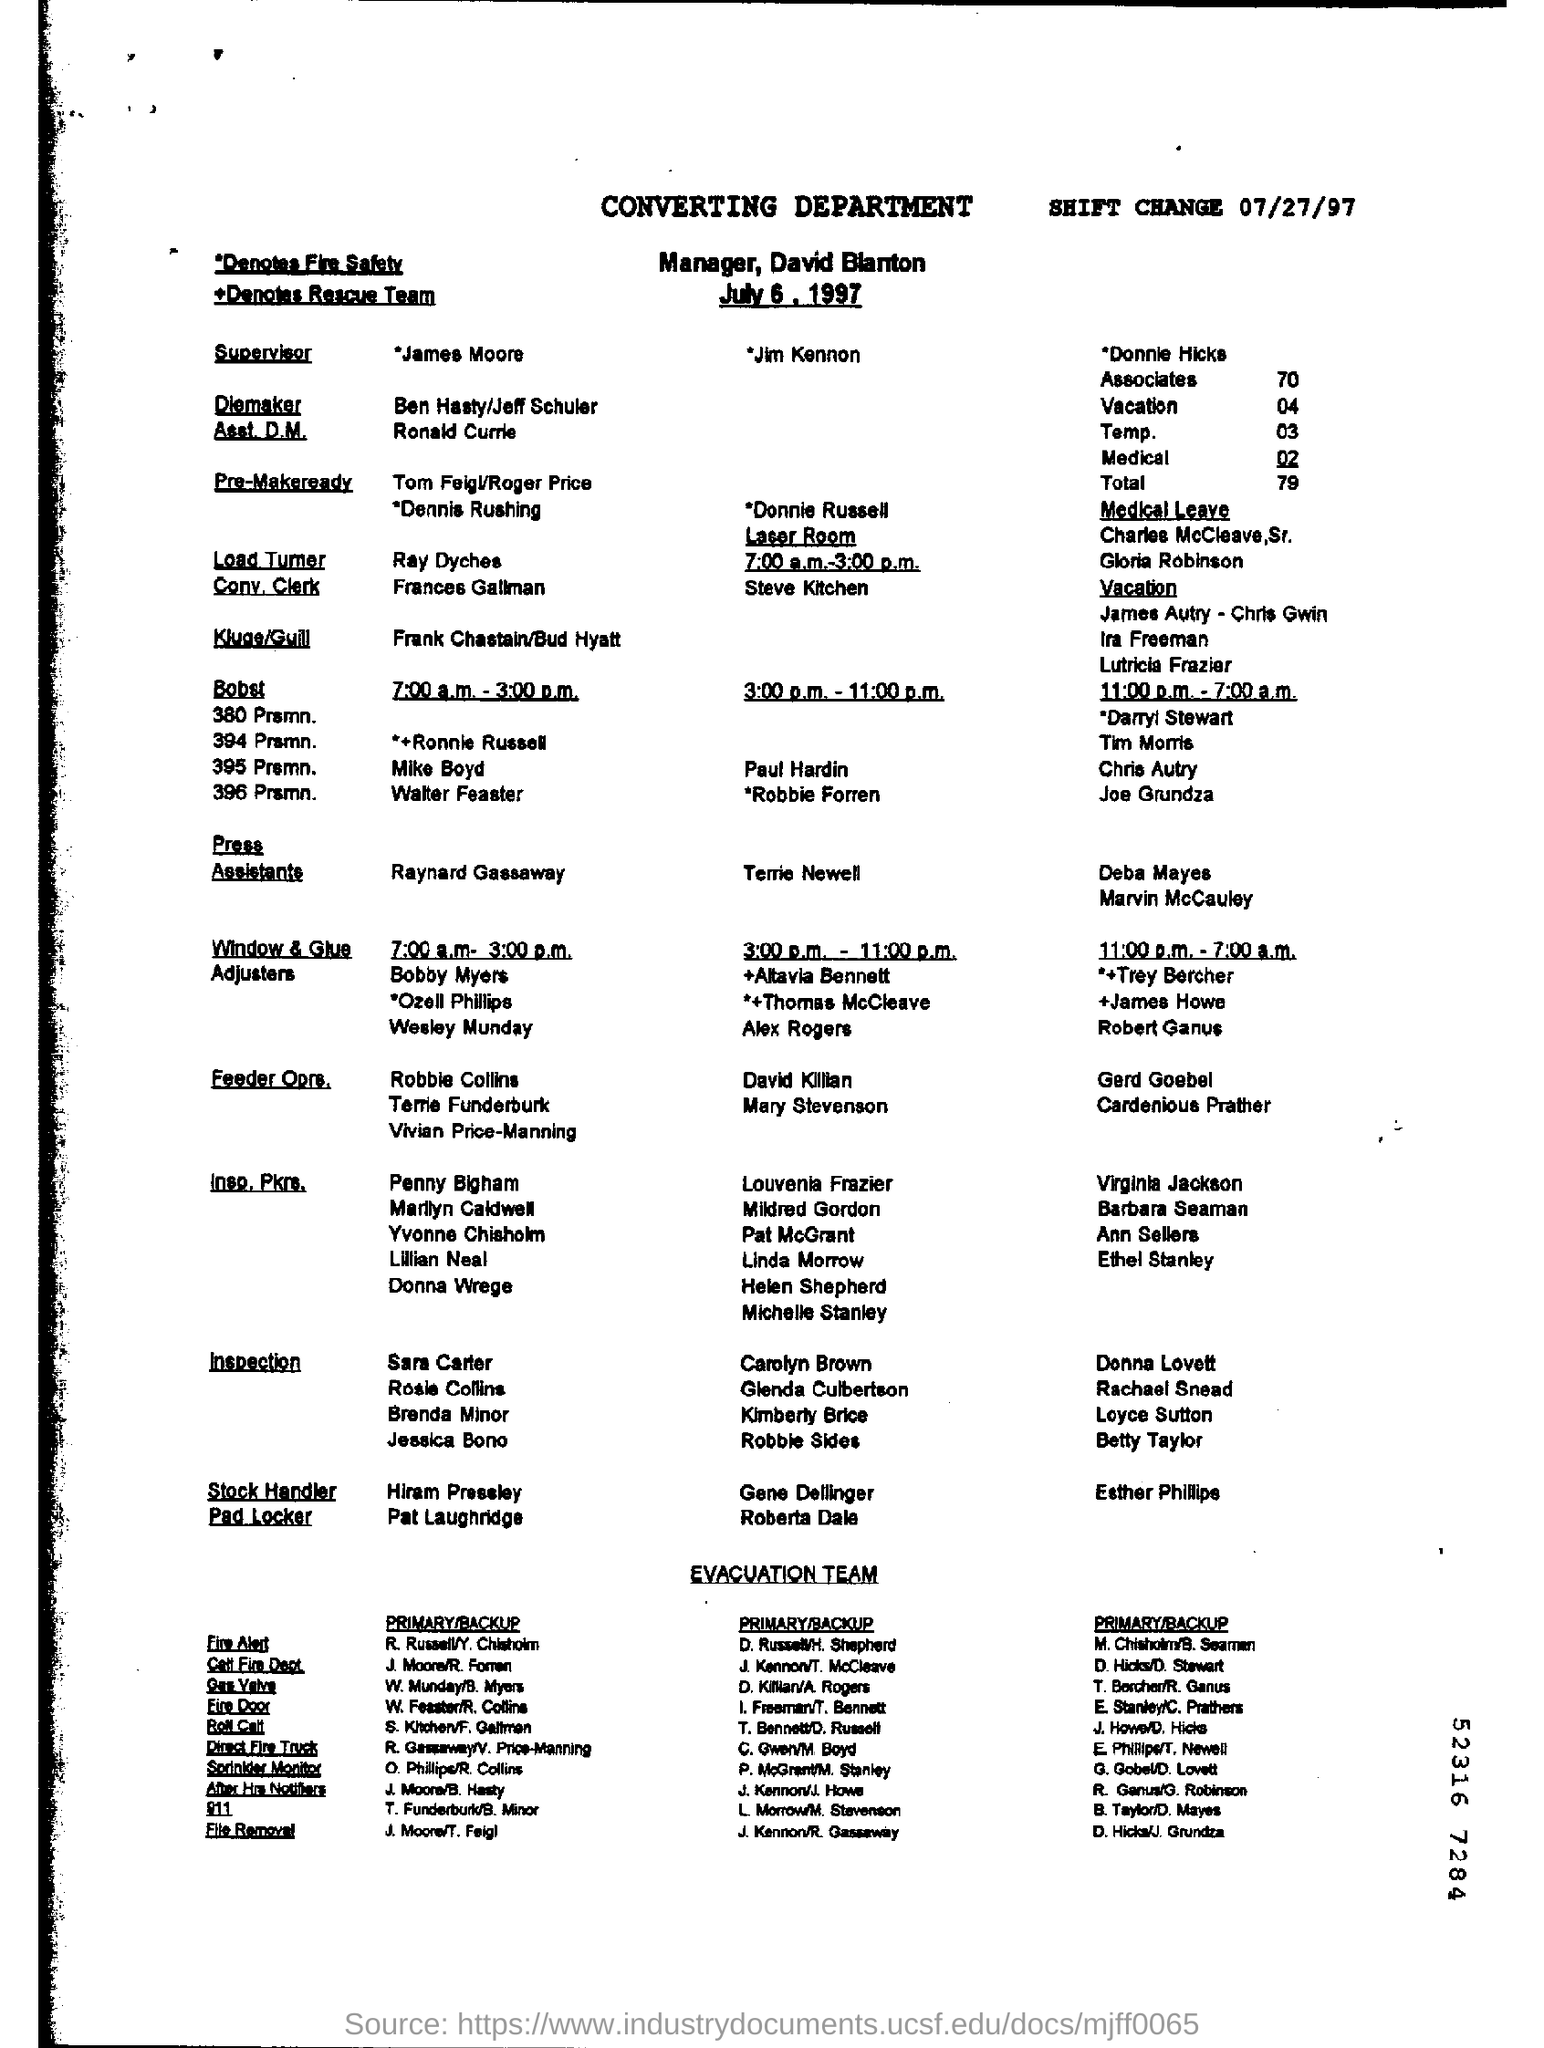Which is the 'SHIFT CHANGE' date?
Your answer should be very brief. 07/27/97. Who is the Manager?
Provide a short and direct response. David Blanton. What is the first shift timings of " Window & Glue Adjusters" ?
Give a very brief answer. 7:00 a.m. - 3:00 p.m. 